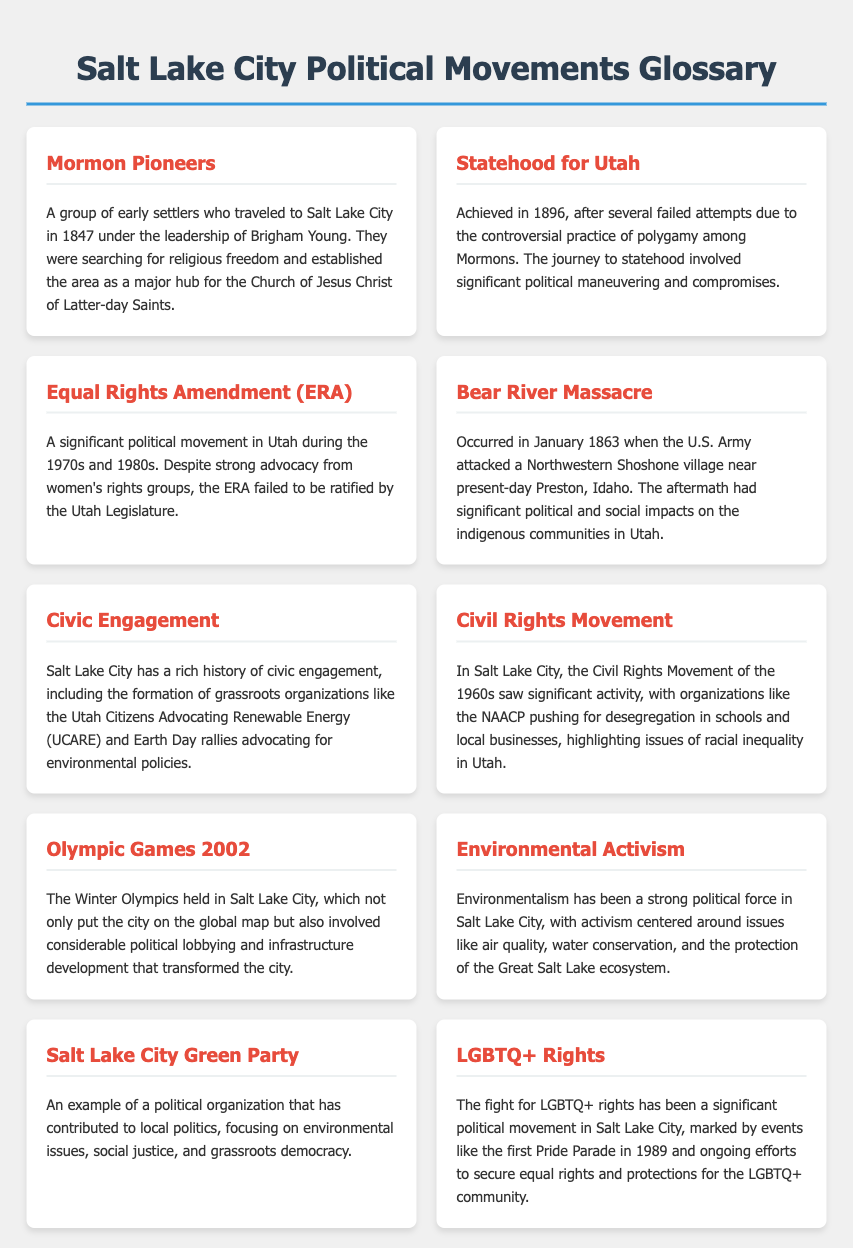What year did Utah achieve statehood? The document states that Utah achieved statehood in 1896.
Answer: 1896 Who led the Mormon Pioneers to Salt Lake City? The leader of the Mormon Pioneers was Brigham Young, as mentioned in the document.
Answer: Brigham Young What significant event occurred in January 1863? The document refers to the Bear River Massacre, which took place in January 1863.
Answer: Bear River Massacre Which political movement in Utah was active during the 1970s and 1980s? The document highlights the Equal Rights Amendment (ERA) as a significant movement during that time.
Answer: Equal Rights Amendment (ERA) What group pushed for desegregation in Salt Lake City during the Civil Rights Movement? The NAACP is mentioned as an organization advocating for desegregation.
Answer: NAACP Which organization's activities center around environmental issues in Salt Lake City? The Salt Lake City Green Party is identified in the document as focusing on environmental issues.
Answer: Salt Lake City Green Party What was a major outcome of the Olympic Games held in Salt Lake City? The document states that the Olympics involved considerable political lobbying and infrastructure development.
Answer: Political lobbying and infrastructure development What year was the first Pride Parade in Salt Lake City? The document states the first Pride Parade occurred in 1989.
Answer: 1989 What is a key focus of environmental activism in Salt Lake City? The document mentions air quality, water conservation, and protection of the Great Salt Lake as key focus areas.
Answer: Air quality, water conservation, and protection of the Great Salt Lake 